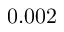Convert formula to latex. <formula><loc_0><loc_0><loc_500><loc_500>0 . 0 0 2</formula> 